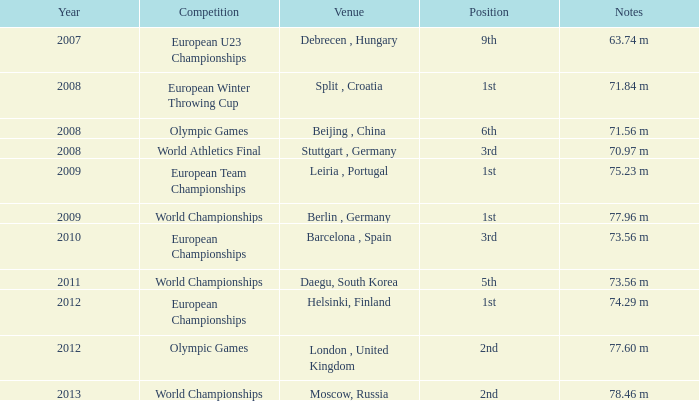What were the notes in 2011? 73.56 m. 